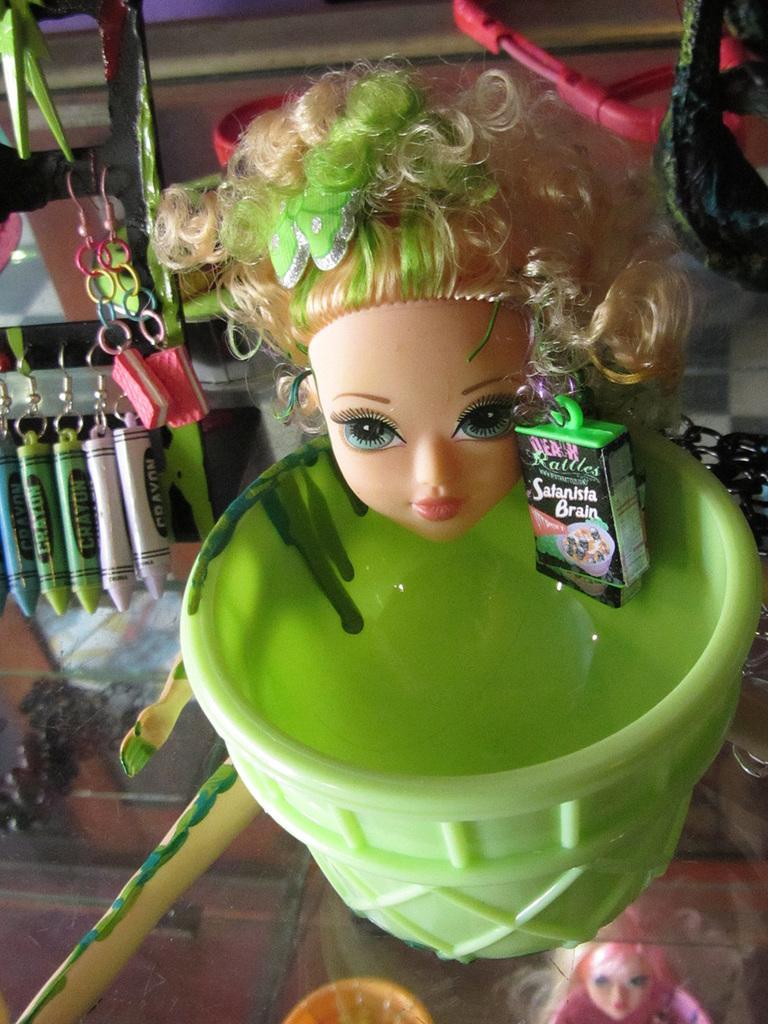How would you summarize this image in a sentence or two? There is a glass table. On that there is a green cup. On the edge of the cup there is a head of the doll. In the back there is a stand with a key chains. Below the glass there is a doll. 